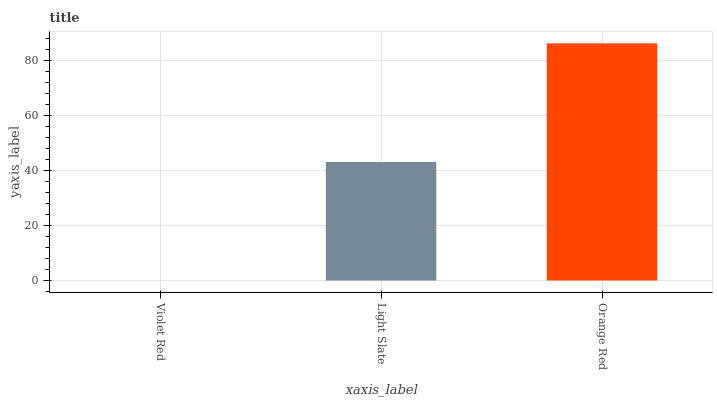Is Light Slate the minimum?
Answer yes or no. No. Is Light Slate the maximum?
Answer yes or no. No. Is Light Slate greater than Violet Red?
Answer yes or no. Yes. Is Violet Red less than Light Slate?
Answer yes or no. Yes. Is Violet Red greater than Light Slate?
Answer yes or no. No. Is Light Slate less than Violet Red?
Answer yes or no. No. Is Light Slate the high median?
Answer yes or no. Yes. Is Light Slate the low median?
Answer yes or no. Yes. Is Violet Red the high median?
Answer yes or no. No. Is Violet Red the low median?
Answer yes or no. No. 